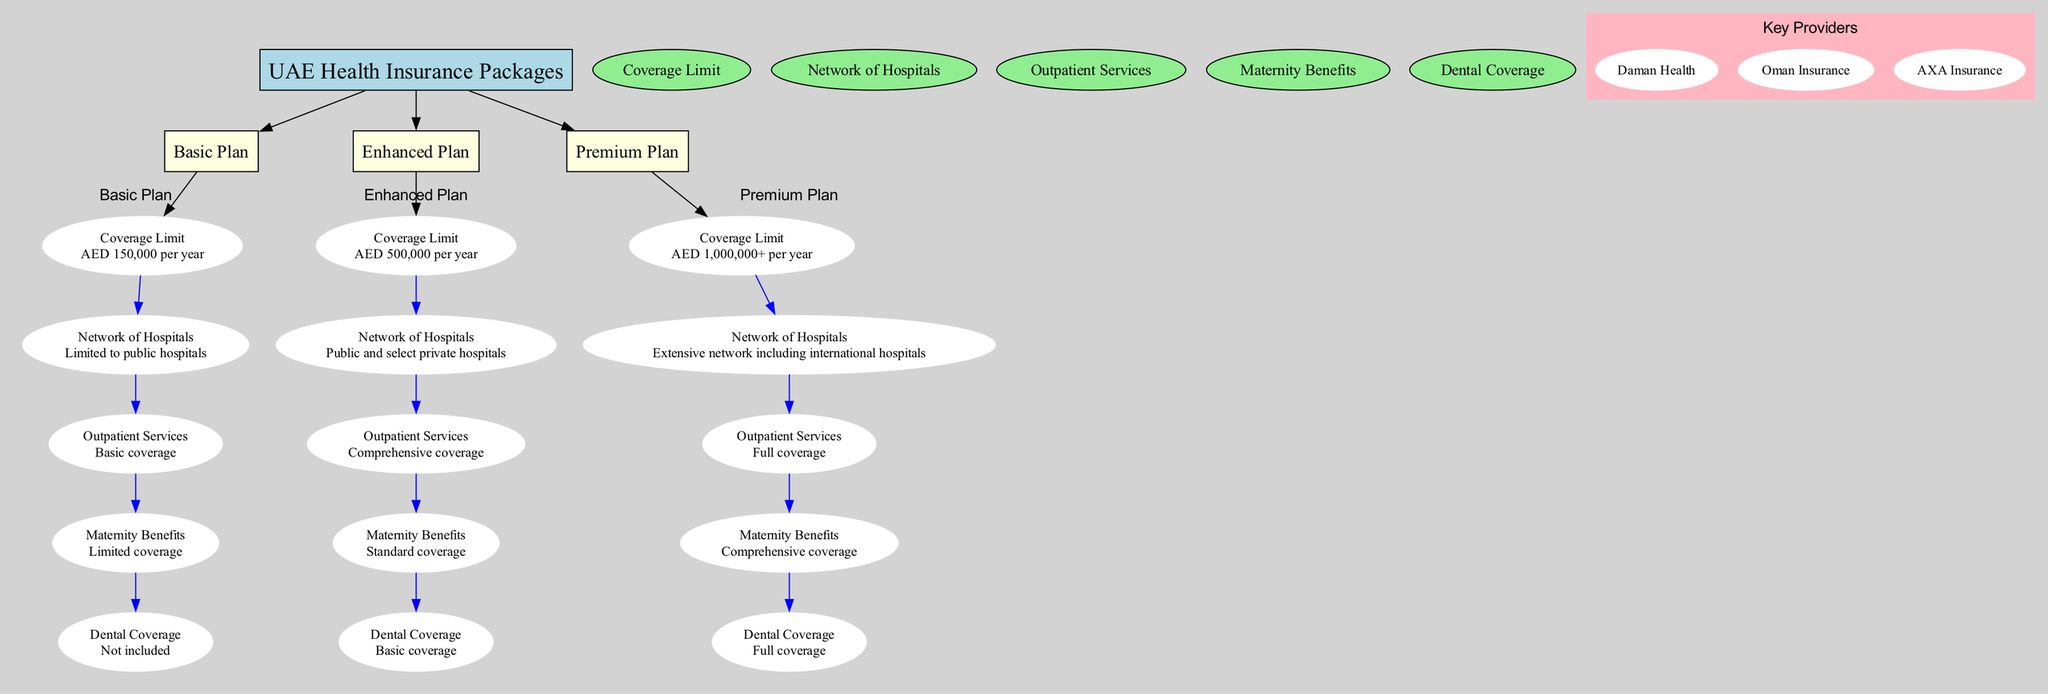What is the coverage limit for the Basic Plan? The diagram indicates that the Basic Plan has a coverage limit of AED 150,000 per year. This information is stated directly under the Basic Plan section.
Answer: AED 150,000 per year How many categories of health insurance plans are shown in the diagram? The diagram visually displays three main categories: Basic Plan, Enhanced Plan, and Premium Plan. By counting these categories, we find that there are three.
Answer: 3 Which plan includes comprehensive maternity benefits? Upon examining the details for each plan, the Premium Plan clearly states it includes comprehensive maternity benefits, while the Basic Plan only offers limited coverage and the Enhanced Plan provides standard coverage.
Answer: Premium Plan What type of hospitals is the Basic Plan limited to? The diagram specifies that the Basic Plan's network is limited to public hospitals. This is directly mentioned in the 'Network of Hospitals' section for the Basic Plan.
Answer: Public hospitals Which plan provides the largest coverage limit? By reviewing the coverage limits provided for each plan, we can see that the Premium Plan offers a coverage limit of AED 1,000,000+. As such, it is the plan with the largest coverage limit.
Answer: AED 1,000,000+ Does the Enhanced Plan include dental coverage? The Enhanced Plan specifies that it includes basic dental coverage. By looking at the dental coverage descriptions, we find that both the Basic Plan has no dental coverage and the Enhanced Plan has basic dental coverage.
Answer: Basic coverage What is the network of hospitals included in the Premium Plan? The Premium Plan is detailed in the diagram to include an extensive network of hospitals, including international hospitals. This clearly outlines the broad accessibility provided by this plan.
Answer: Extensive network including international hospitals How many comparison criteria are used in the diagram? The diagram outlines five comparison criteria: Coverage Limit, Network of Hospitals, Outpatient Services, Maternity Benefits, and Dental Coverage. By counting these criteria, we arrive at the total of five.
Answer: 5 Which provider is NOT listed as a key provider in the diagram? The diagram presents the key providers as Daman Health, Oman Insurance, and AXA Insurance. Thus any provider not listed among these three, such as Zurich Insurance, is not a key provider according to this diagram.
Answer: N/A (any provider not listed) 